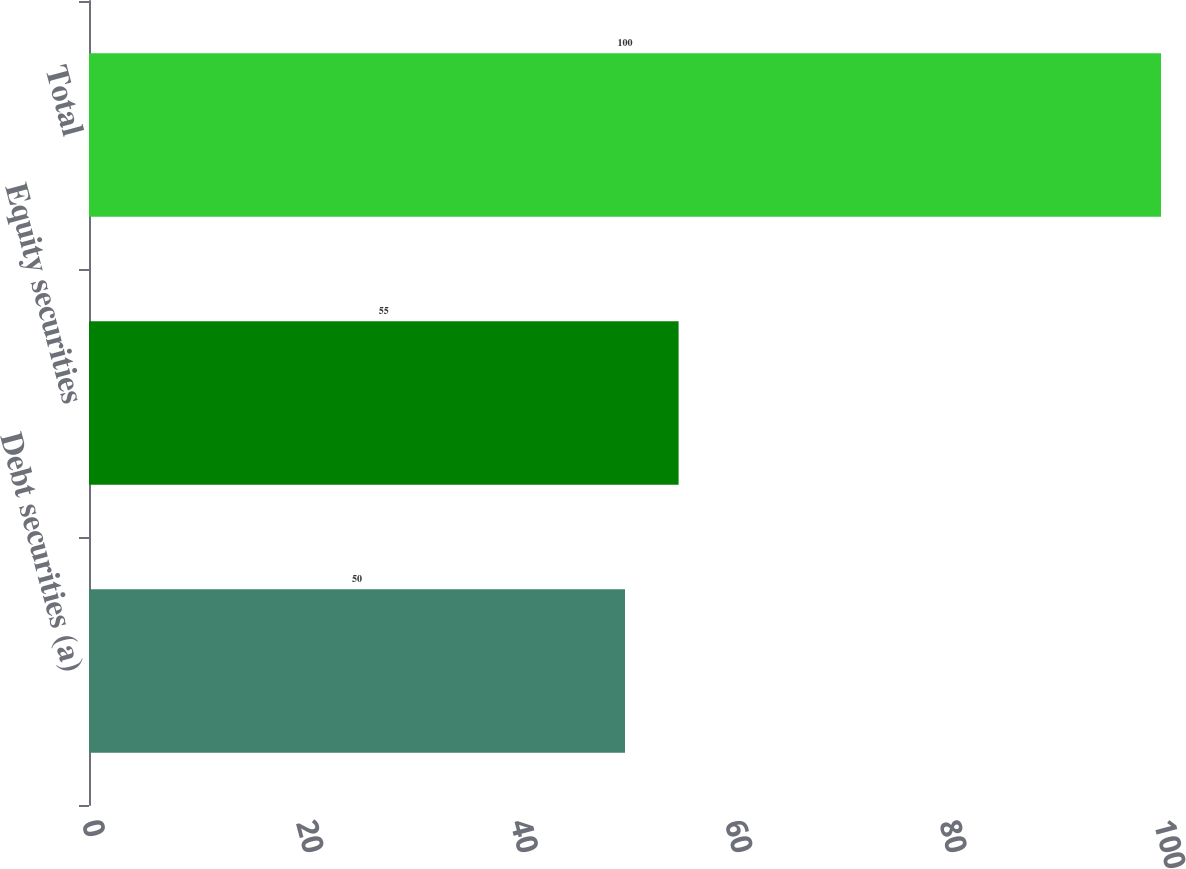Convert chart to OTSL. <chart><loc_0><loc_0><loc_500><loc_500><bar_chart><fcel>Debt securities (a)<fcel>Equity securities<fcel>Total<nl><fcel>50<fcel>55<fcel>100<nl></chart> 